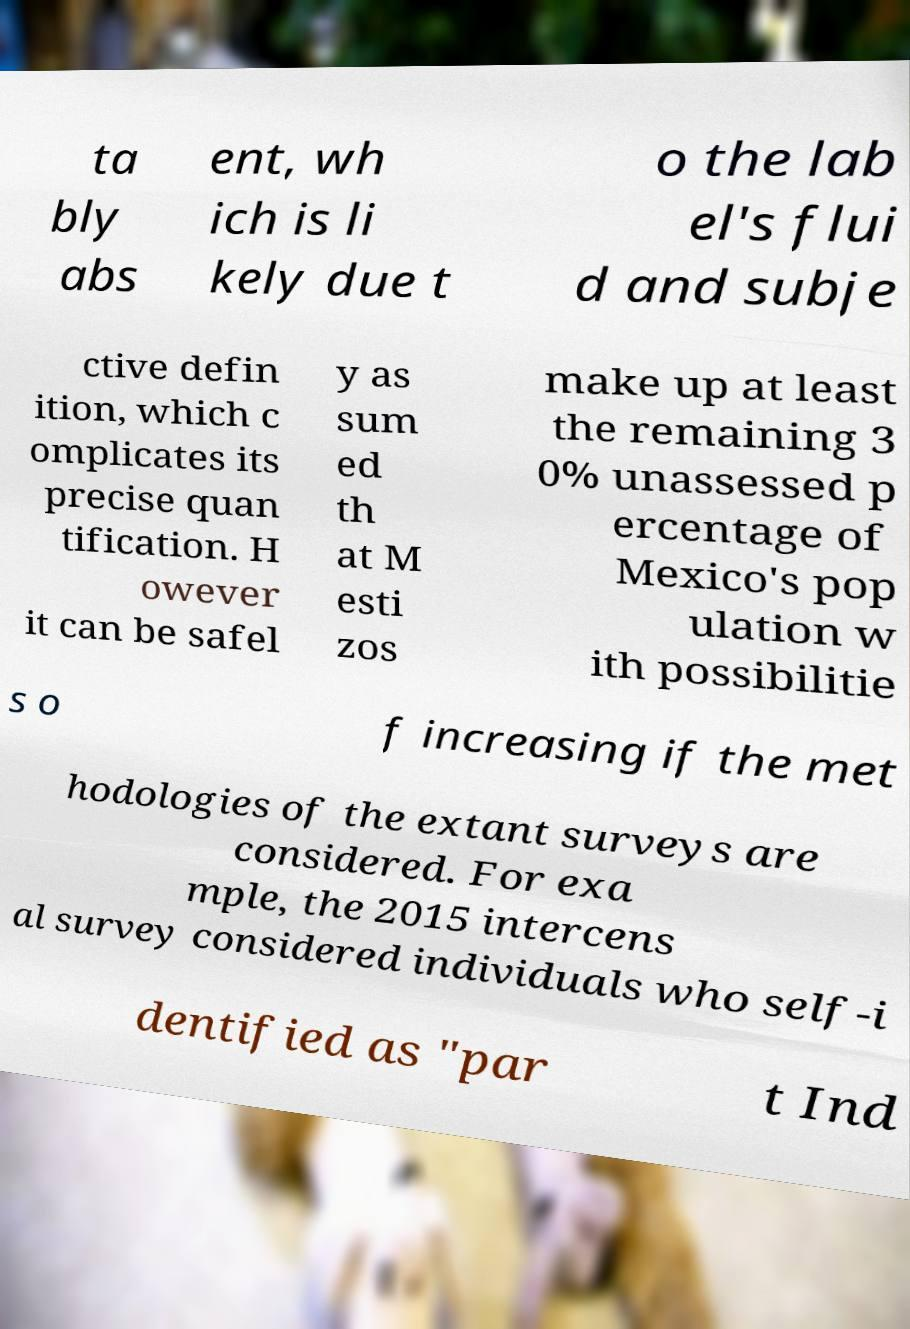Can you read and provide the text displayed in the image?This photo seems to have some interesting text. Can you extract and type it out for me? ta bly abs ent, wh ich is li kely due t o the lab el's flui d and subje ctive defin ition, which c omplicates its precise quan tification. H owever it can be safel y as sum ed th at M esti zos make up at least the remaining 3 0% unassessed p ercentage of Mexico's pop ulation w ith possibilitie s o f increasing if the met hodologies of the extant surveys are considered. For exa mple, the 2015 intercens al survey considered individuals who self-i dentified as "par t Ind 